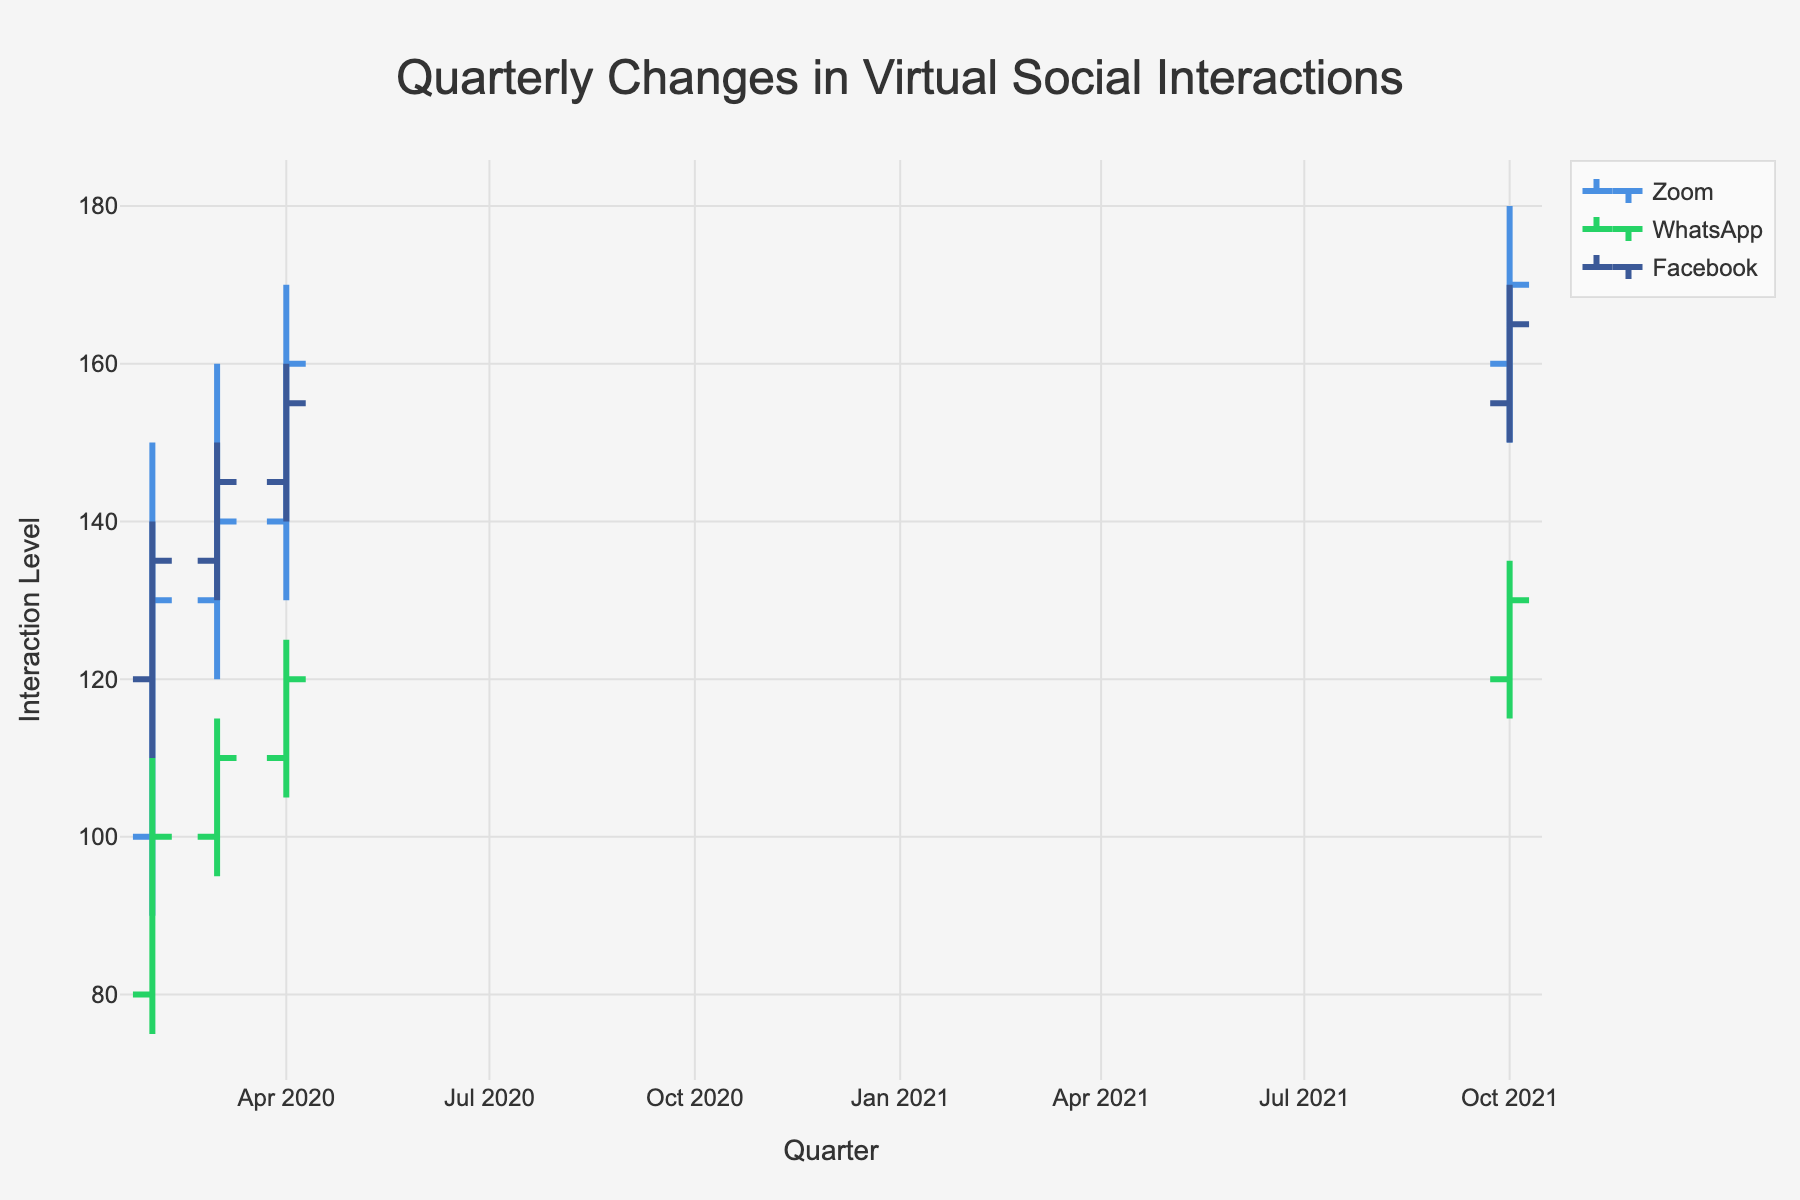What platforms are included in the chart? The platforms are labeled in the legend of the chart. Each platform is represented by a specific color. The platforms included are Zoom (blue), WhatsApp (green), and Facebook (blue).
Answer: Zoom, WhatsApp, Facebook Which platform saw the largest increase from Q2 2020 to Q3 2020 in their closing values? To determine the largest increase, we compare the closing values in Q2 2020 with the closing values in Q3 2020 for each platform. For Zoom, this is an increase from 130 to 140 (10 points). For WhatsApp, the increase is from 100 to 110 (10 points). For Facebook, the increase is from 135 to 145 (10 points). All platforms saw the same increase of 10 points.
Answer: All platforms saw the same increase What was the high value for WhatsApp in Q4 2020? Locate the high value of the OHLC bar for WhatsApp in Q4 2020. It shows the highest level of virtual social interaction, represented as 125.
Answer: 125 Which platform had the highest low value in Q1 2021? By examining the low values for each platform in Q1 2021, we see that Zoom had a lowest value of 150, WhatsApp 115, and Facebook 150. Zoom and Facebook had the same highest low value of 150.
Answer: Zoom, Facebook What is the color used to represent Facebook in the chart? The legend indicates that Facebook is represented by a navy blue color.
Answer: Blue Which quarter had the highest closing value for Zoom? Looking at the closing values for Zoom in each quarter, Q1 2021 had the highest closing value of 170.
Answer: Q1 2021 What is the difference between the high and low values for Facebook in Q3 2020? For Facebook in Q3 2020, the high value is 150, and the low value is 130. The difference is calculated as 150 - 130 = 20.
Answer: 20 How did the interaction levels for WhatsApp change from Q3 2020 to Q4 2020? For Q3 2020, the low, high, and closing values for WhatsApp were 95, 115, and 110, respectively. For Q4 2020, these values were 105, 125, and 120, respectively. Interaction levels increased from 95 to 105 for low, from 115 to 125 for high, and from 110 to 120 for closing.
Answer: Increased In which quarter did Facebook have the highest closing value? Facebook's closing values in the chart are 135 for Q2 2020, 145 for Q3 2020, 155 for Q4 2020, and 165 for Q1 2021. The highest is in Q1 2021 which is 165.
Answer: Q1 2021 How do the high values for Zoom compare across all quarters? Zoom's high values for each quarter are Q2 2020 (150), Q3 2020 (160), Q4 2020 (170), and Q1 2021 (180). These values show a consistent increase each quarter.
Answer: Increasing each quarter 